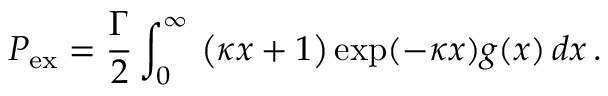Convert formula to latex. <formula><loc_0><loc_0><loc_500><loc_500>P _ { e x } = \frac { \Gamma } { 2 } \int _ { 0 } ^ { \infty } \ \left ( \kappa x + 1 \right ) \exp ( - \kappa x ) g ( x ) \, d x \, .</formula> 